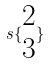<formula> <loc_0><loc_0><loc_500><loc_500>s \{ \begin{matrix} 2 \\ 3 \end{matrix} \}</formula> 